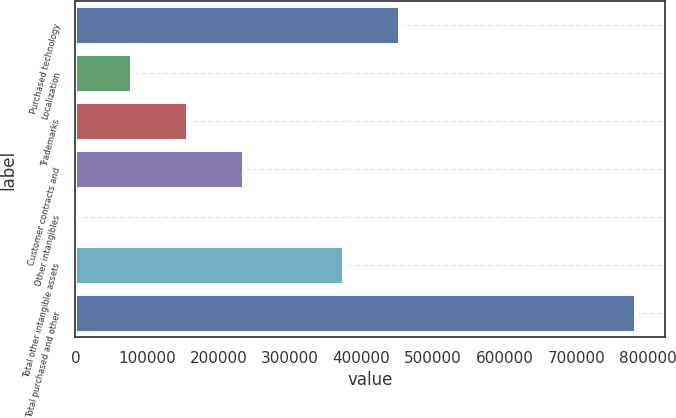Convert chart. <chart><loc_0><loc_0><loc_500><loc_500><bar_chart><fcel>Purchased technology<fcel>Localization<fcel>Trademarks<fcel>Customer contracts and<fcel>Other intangibles<fcel>Total other intangible assets<fcel>Total purchased and other<nl><fcel>453440<fcel>79140.9<fcel>157482<fcel>235823<fcel>800<fcel>375099<fcel>784209<nl></chart> 